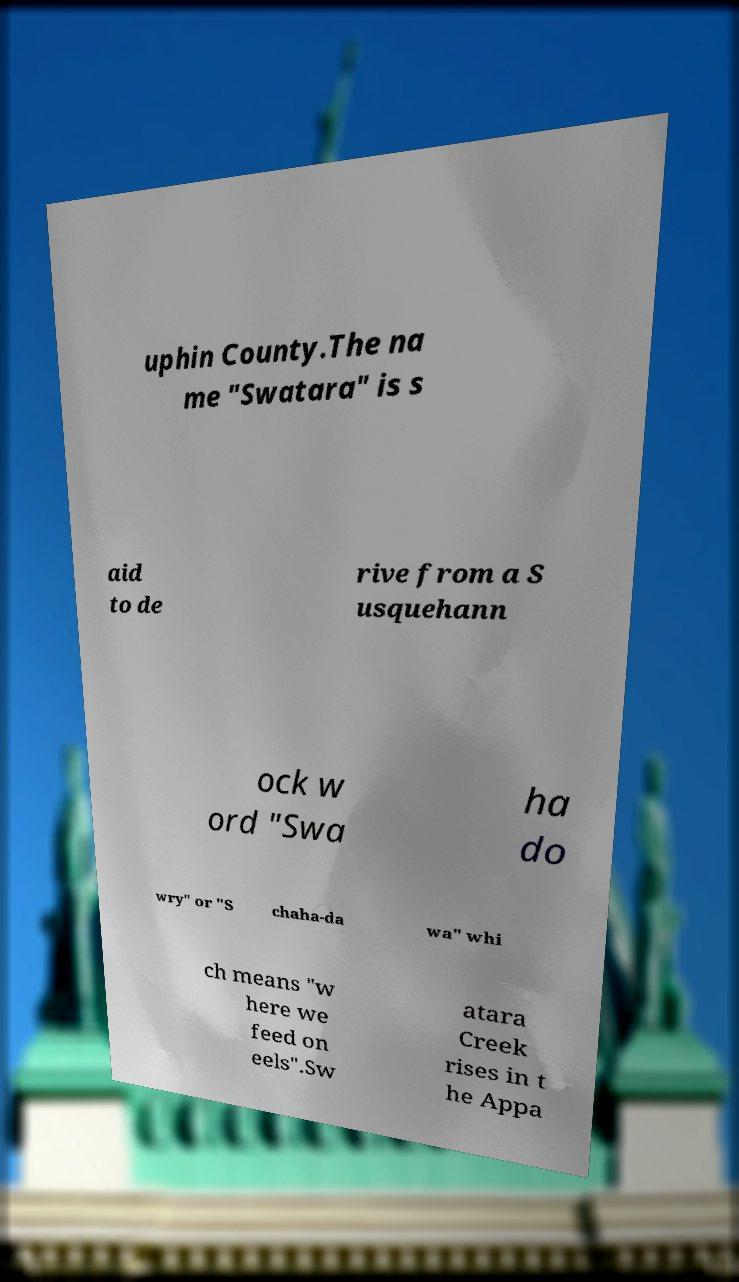Can you accurately transcribe the text from the provided image for me? uphin County.The na me "Swatara" is s aid to de rive from a S usquehann ock w ord "Swa ha do wry" or "S chaha-da wa" whi ch means "w here we feed on eels".Sw atara Creek rises in t he Appa 